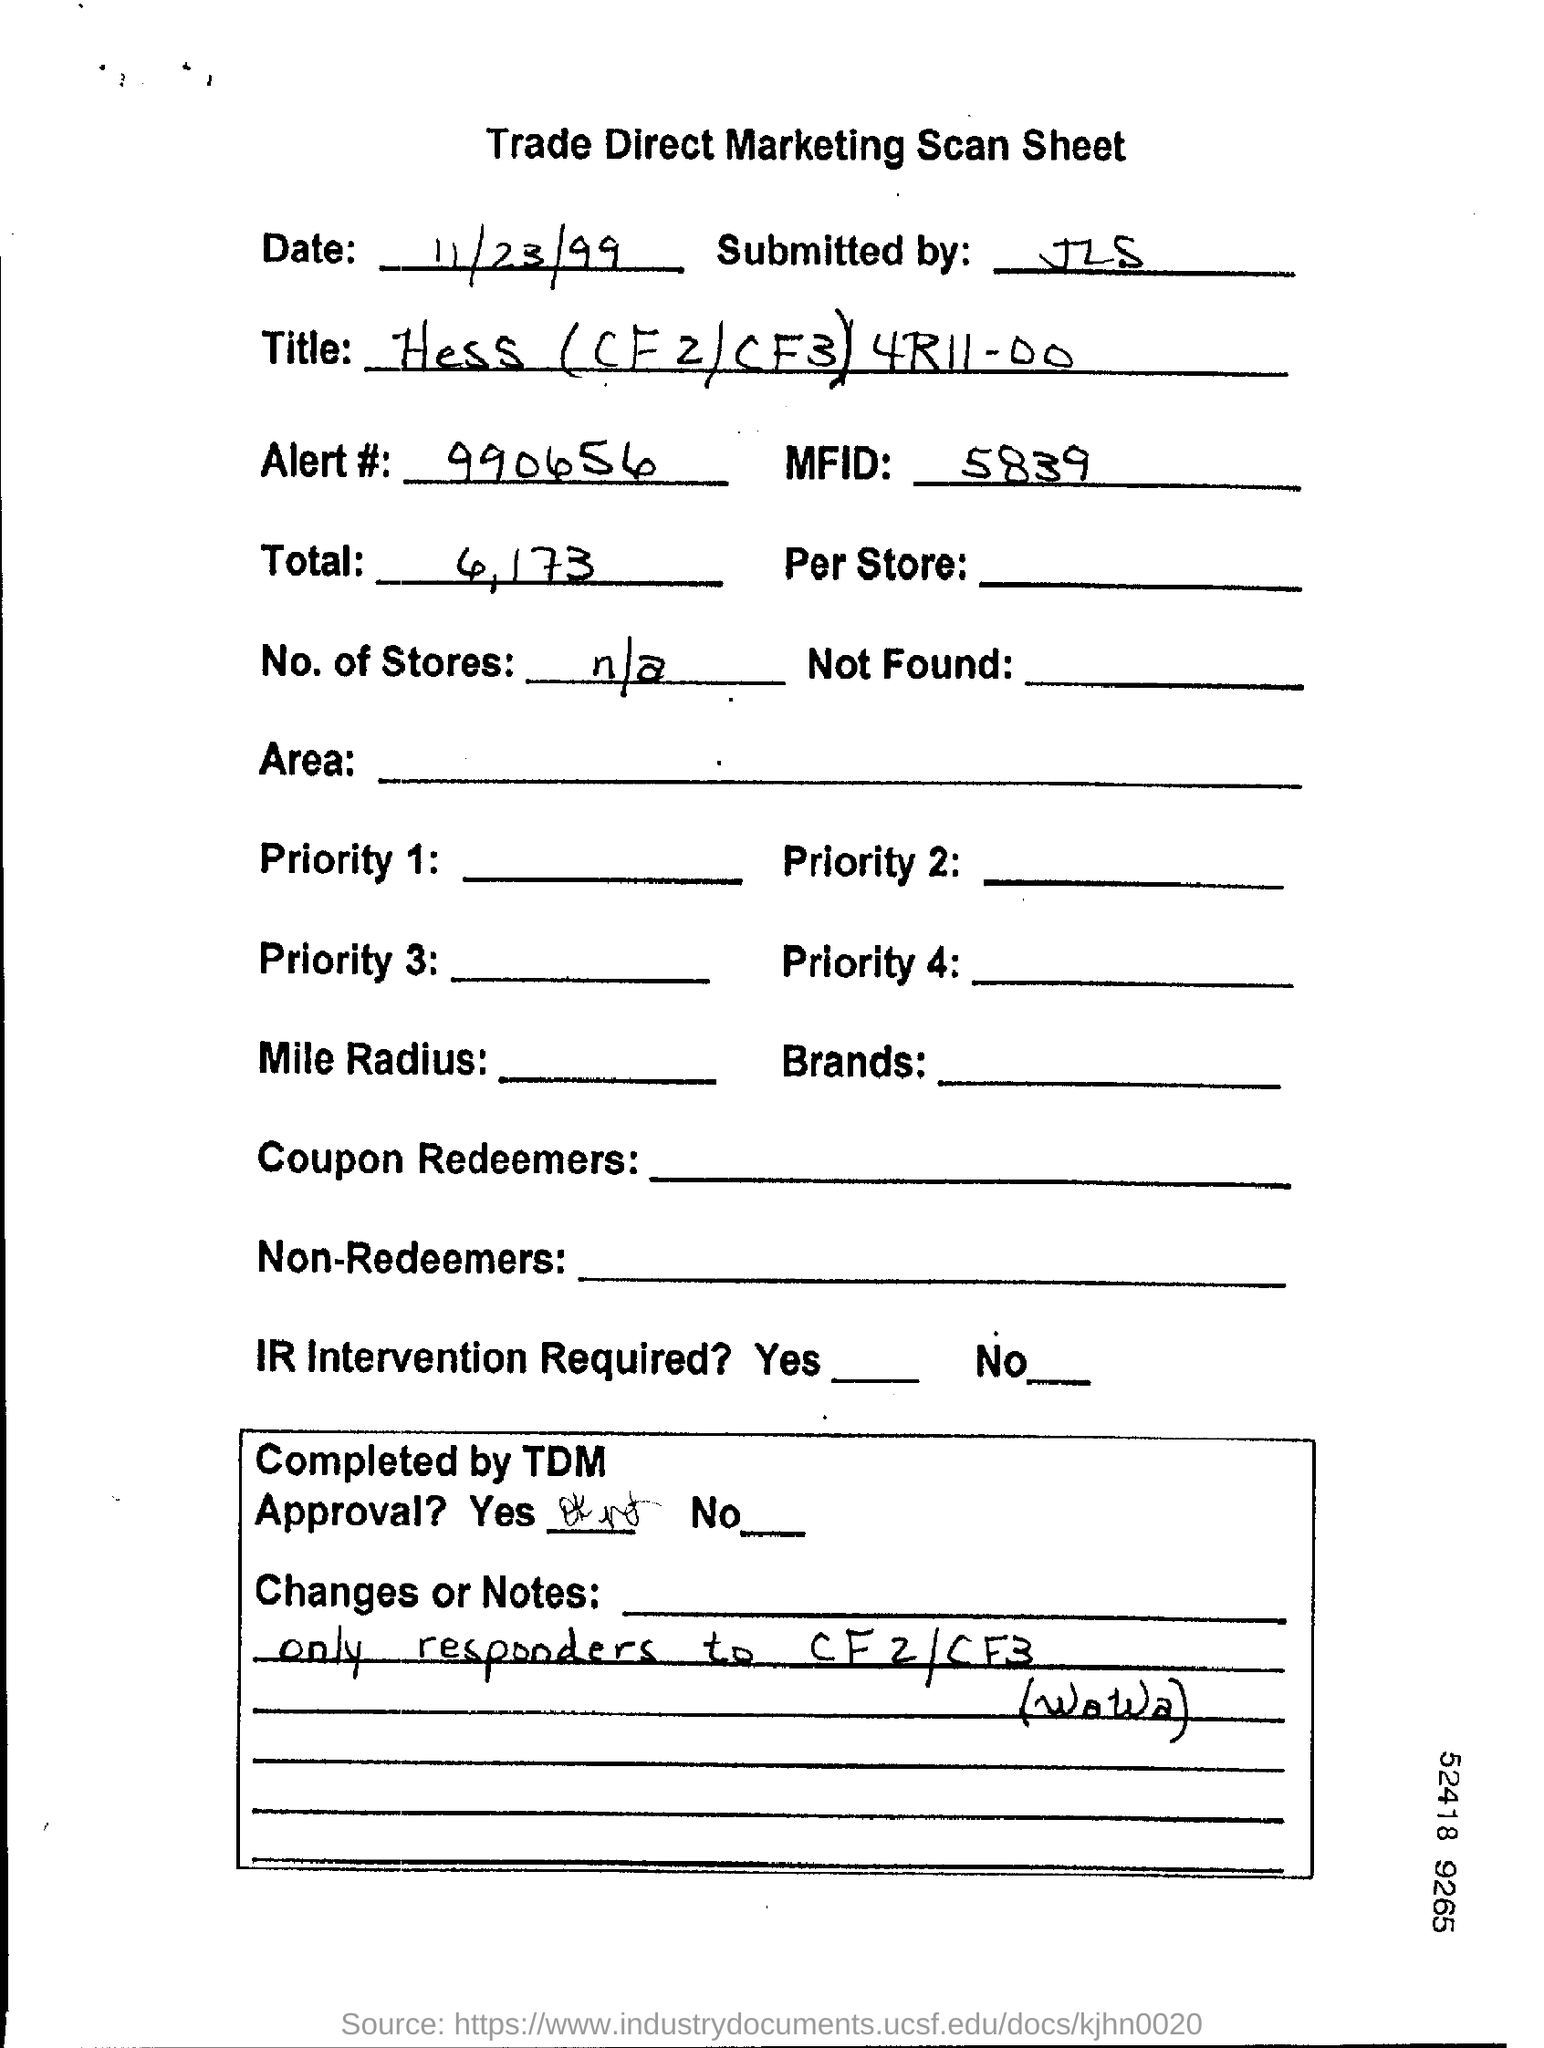What kind of document is this?
Your answer should be very brief. Trade Direct Marketing Scan Sheet. What is the date mentioned in this document?
Provide a succinct answer. 11/23/99. What is the Alert # given in the document?
Your answer should be compact. 990656. 